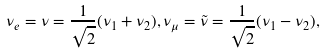Convert formula to latex. <formula><loc_0><loc_0><loc_500><loc_500>\nu _ { e } = \nu = \frac { 1 } { \sqrt { 2 } } ( \nu _ { 1 } + \nu _ { 2 } ) , \nu _ { \mu } = \tilde { \nu } = \frac { 1 } { \sqrt { 2 } } ( \nu _ { 1 } - \nu _ { 2 } ) ,</formula> 